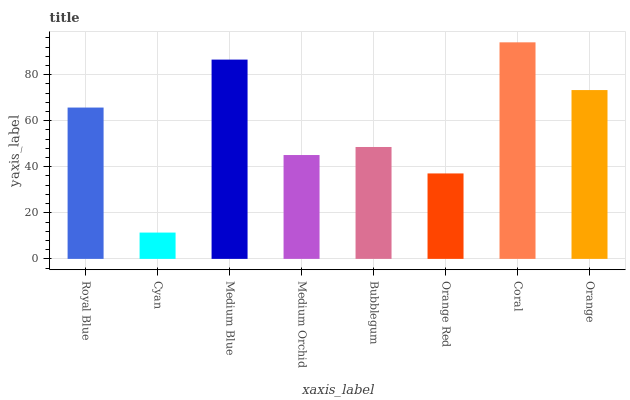Is Cyan the minimum?
Answer yes or no. Yes. Is Coral the maximum?
Answer yes or no. Yes. Is Medium Blue the minimum?
Answer yes or no. No. Is Medium Blue the maximum?
Answer yes or no. No. Is Medium Blue greater than Cyan?
Answer yes or no. Yes. Is Cyan less than Medium Blue?
Answer yes or no. Yes. Is Cyan greater than Medium Blue?
Answer yes or no. No. Is Medium Blue less than Cyan?
Answer yes or no. No. Is Royal Blue the high median?
Answer yes or no. Yes. Is Bubblegum the low median?
Answer yes or no. Yes. Is Bubblegum the high median?
Answer yes or no. No. Is Cyan the low median?
Answer yes or no. No. 